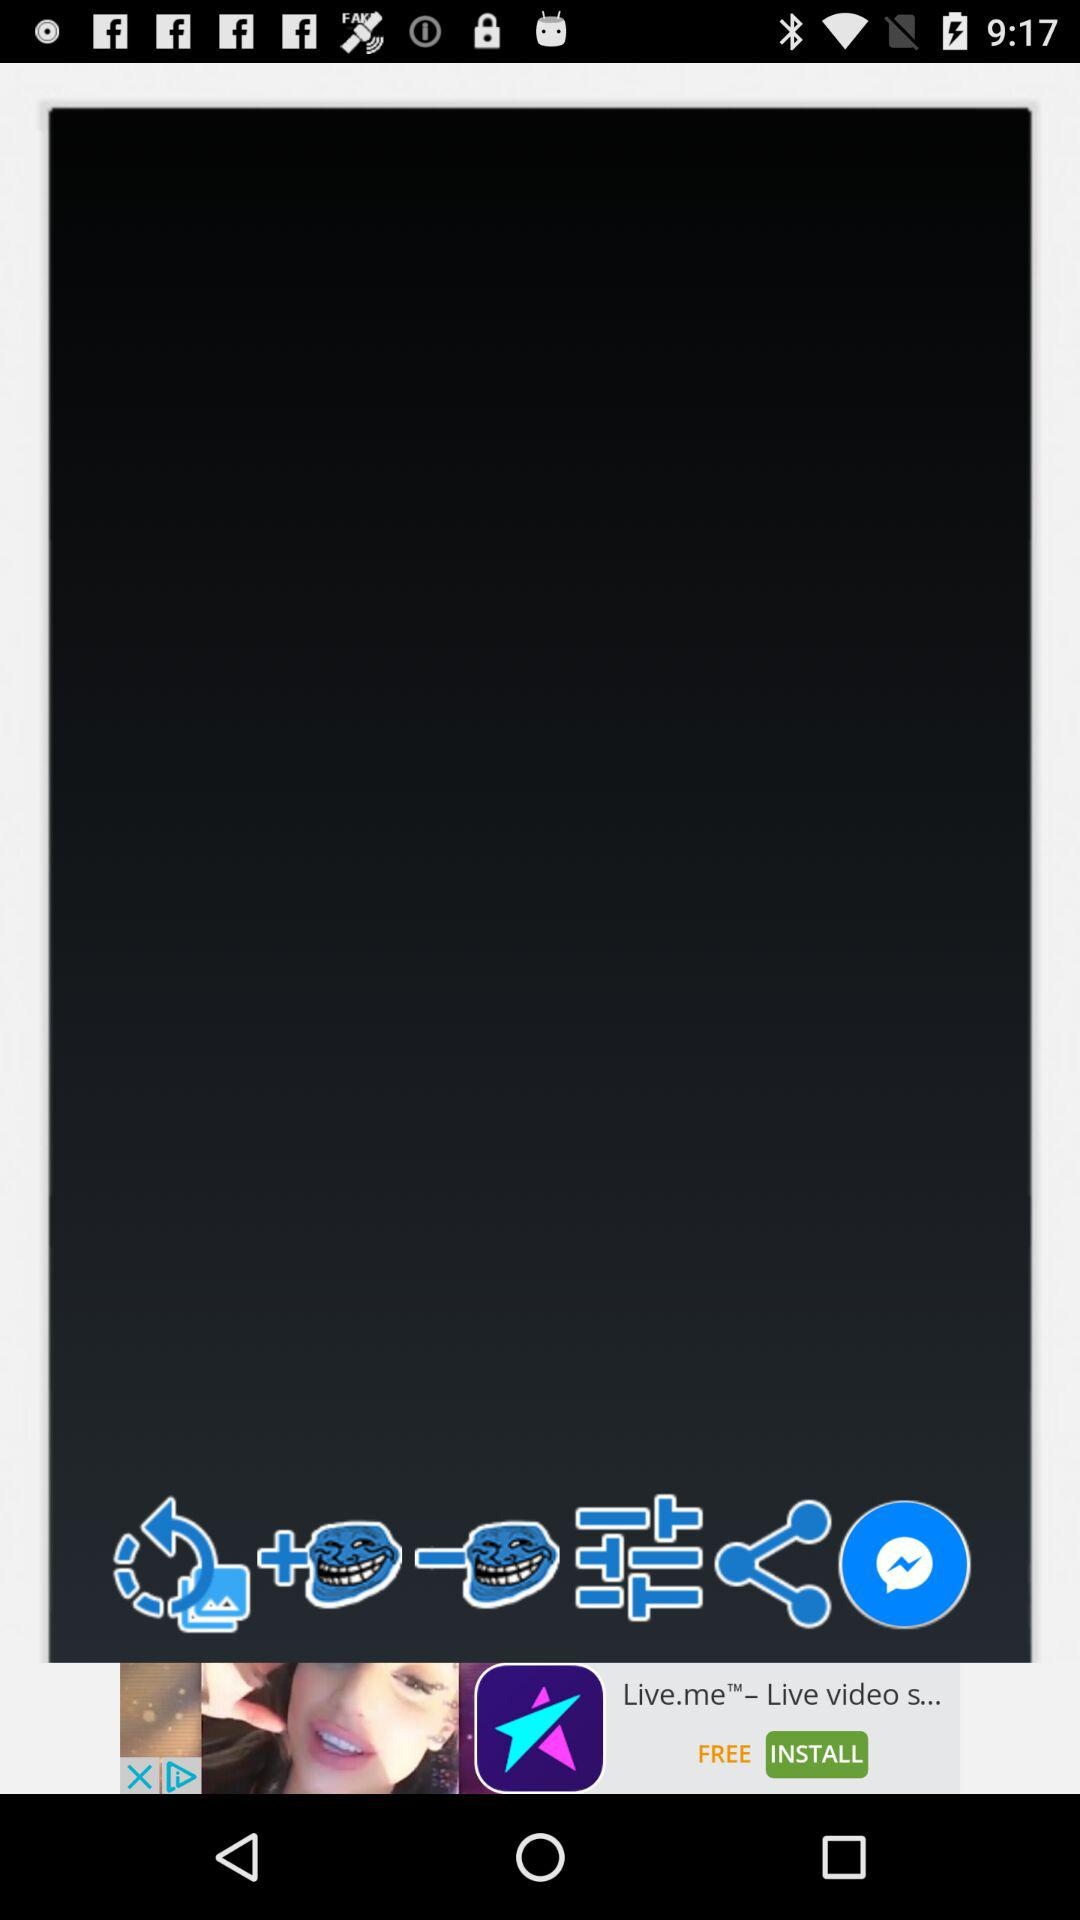How many troll face stickers are there?
Answer the question using a single word or phrase. 2 